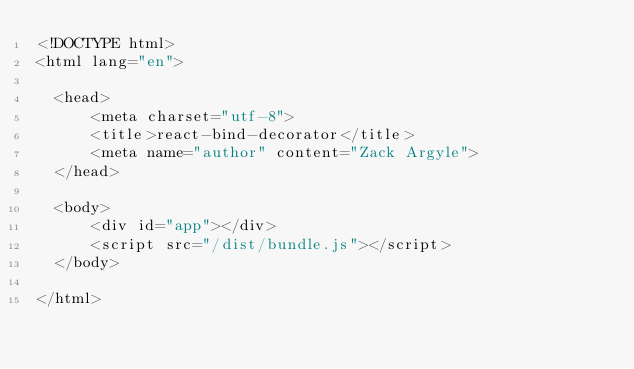<code> <loc_0><loc_0><loc_500><loc_500><_HTML_><!DOCTYPE html>
<html lang="en">

  <head>
      <meta charset="utf-8">
      <title>react-bind-decorator</title>
      <meta name="author" content="Zack Argyle">
  </head>

  <body>
      <div id="app"></div>
      <script src="/dist/bundle.js"></script>
  </body>

</html></code> 